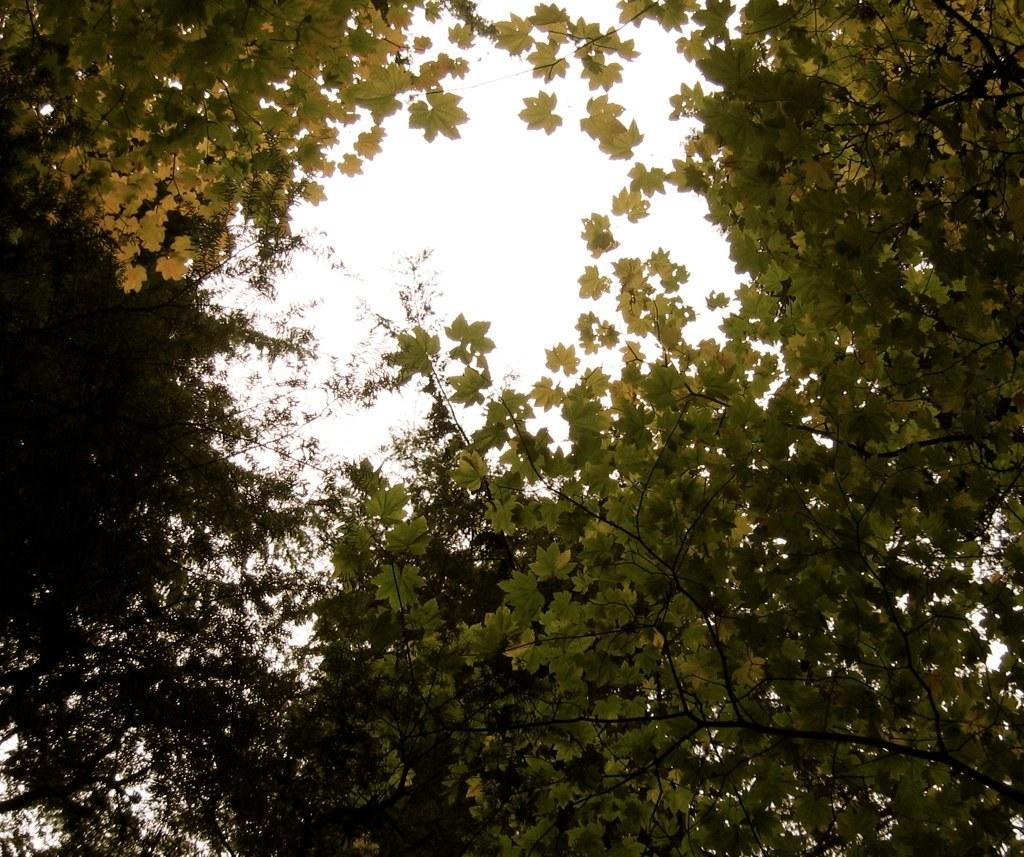Where was the picture taken? The picture was clicked outside. What can be seen in the foreground of the image? There are trees in the foreground of the image. What is visible in the background of the image? The sky is visible in the background of the image. What type of brain can be seen in the image? There is no brain present in the image; it features trees in the foreground and the sky in the background. 